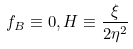Convert formula to latex. <formula><loc_0><loc_0><loc_500><loc_500>f _ { B } \equiv 0 , H \equiv \frac { \xi } { 2 \eta ^ { 2 } }</formula> 